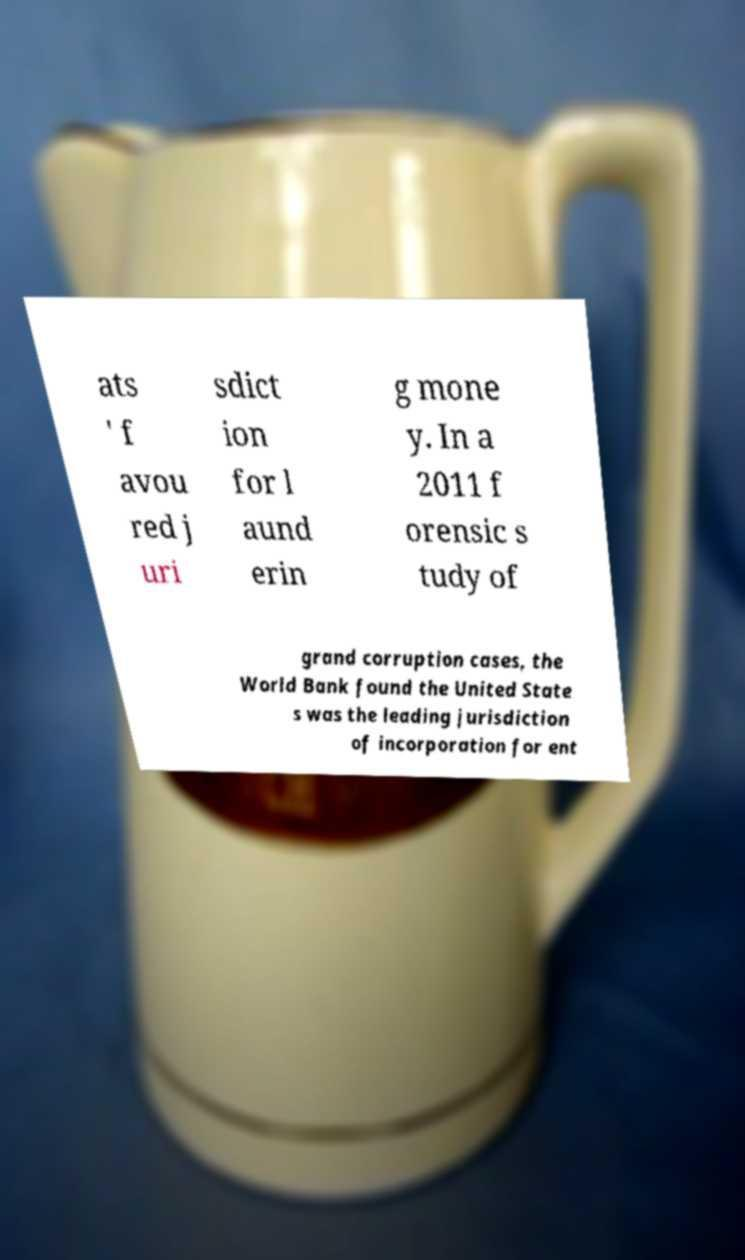Please read and relay the text visible in this image. What does it say? ats ' f avou red j uri sdict ion for l aund erin g mone y. In a 2011 f orensic s tudy of grand corruption cases, the World Bank found the United State s was the leading jurisdiction of incorporation for ent 